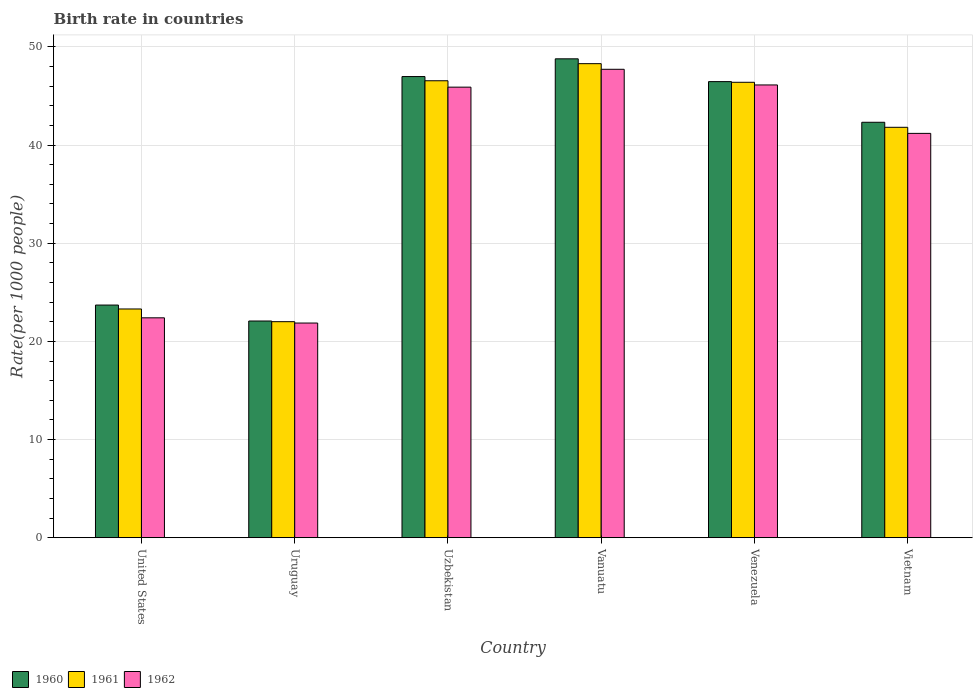Are the number of bars per tick equal to the number of legend labels?
Give a very brief answer. Yes. Are the number of bars on each tick of the X-axis equal?
Provide a short and direct response. Yes. How many bars are there on the 5th tick from the right?
Your response must be concise. 3. What is the label of the 3rd group of bars from the left?
Your answer should be very brief. Uzbekistan. What is the birth rate in 1960 in Uzbekistan?
Your answer should be compact. 46.98. Across all countries, what is the maximum birth rate in 1960?
Your response must be concise. 48.78. Across all countries, what is the minimum birth rate in 1961?
Your response must be concise. 22.01. In which country was the birth rate in 1960 maximum?
Offer a very short reply. Vanuatu. In which country was the birth rate in 1961 minimum?
Offer a terse response. Uruguay. What is the total birth rate in 1960 in the graph?
Offer a very short reply. 230.31. What is the difference between the birth rate in 1962 in Uzbekistan and that in Venezuela?
Make the answer very short. -0.22. What is the difference between the birth rate in 1960 in Vietnam and the birth rate in 1961 in Uruguay?
Offer a terse response. 20.31. What is the average birth rate in 1962 per country?
Your answer should be compact. 37.53. What is the difference between the birth rate of/in 1960 and birth rate of/in 1962 in Uzbekistan?
Offer a terse response. 1.08. In how many countries, is the birth rate in 1961 greater than 36?
Make the answer very short. 4. What is the ratio of the birth rate in 1961 in Venezuela to that in Vietnam?
Your answer should be very brief. 1.11. What is the difference between the highest and the second highest birth rate in 1961?
Your answer should be very brief. 1.9. What is the difference between the highest and the lowest birth rate in 1962?
Ensure brevity in your answer.  25.85. Is the sum of the birth rate in 1960 in Vanuatu and Vietnam greater than the maximum birth rate in 1961 across all countries?
Offer a very short reply. Yes. Are all the bars in the graph horizontal?
Your answer should be compact. No. How many countries are there in the graph?
Offer a terse response. 6. What is the difference between two consecutive major ticks on the Y-axis?
Provide a short and direct response. 10. Are the values on the major ticks of Y-axis written in scientific E-notation?
Offer a terse response. No. Does the graph contain any zero values?
Give a very brief answer. No. Does the graph contain grids?
Your answer should be compact. Yes. How many legend labels are there?
Give a very brief answer. 3. What is the title of the graph?
Ensure brevity in your answer.  Birth rate in countries. What is the label or title of the Y-axis?
Your answer should be compact. Rate(per 1000 people). What is the Rate(per 1000 people) of 1960 in United States?
Your answer should be compact. 23.7. What is the Rate(per 1000 people) of 1961 in United States?
Offer a very short reply. 23.3. What is the Rate(per 1000 people) in 1962 in United States?
Keep it short and to the point. 22.4. What is the Rate(per 1000 people) of 1960 in Uruguay?
Ensure brevity in your answer.  22.07. What is the Rate(per 1000 people) of 1961 in Uruguay?
Make the answer very short. 22.01. What is the Rate(per 1000 people) in 1962 in Uruguay?
Offer a terse response. 21.87. What is the Rate(per 1000 people) of 1960 in Uzbekistan?
Make the answer very short. 46.98. What is the Rate(per 1000 people) of 1961 in Uzbekistan?
Keep it short and to the point. 46.55. What is the Rate(per 1000 people) in 1962 in Uzbekistan?
Give a very brief answer. 45.9. What is the Rate(per 1000 people) in 1960 in Vanuatu?
Provide a succinct answer. 48.78. What is the Rate(per 1000 people) of 1961 in Vanuatu?
Ensure brevity in your answer.  48.29. What is the Rate(per 1000 people) of 1962 in Vanuatu?
Offer a terse response. 47.72. What is the Rate(per 1000 people) of 1960 in Venezuela?
Give a very brief answer. 46.46. What is the Rate(per 1000 people) of 1961 in Venezuela?
Provide a short and direct response. 46.39. What is the Rate(per 1000 people) of 1962 in Venezuela?
Make the answer very short. 46.12. What is the Rate(per 1000 people) in 1960 in Vietnam?
Keep it short and to the point. 42.32. What is the Rate(per 1000 people) in 1961 in Vietnam?
Give a very brief answer. 41.81. What is the Rate(per 1000 people) of 1962 in Vietnam?
Your answer should be very brief. 41.19. Across all countries, what is the maximum Rate(per 1000 people) in 1960?
Provide a short and direct response. 48.78. Across all countries, what is the maximum Rate(per 1000 people) of 1961?
Your answer should be very brief. 48.29. Across all countries, what is the maximum Rate(per 1000 people) of 1962?
Provide a succinct answer. 47.72. Across all countries, what is the minimum Rate(per 1000 people) in 1960?
Your answer should be very brief. 22.07. Across all countries, what is the minimum Rate(per 1000 people) of 1961?
Your response must be concise. 22.01. Across all countries, what is the minimum Rate(per 1000 people) of 1962?
Ensure brevity in your answer.  21.87. What is the total Rate(per 1000 people) in 1960 in the graph?
Your answer should be very brief. 230.31. What is the total Rate(per 1000 people) in 1961 in the graph?
Give a very brief answer. 228.34. What is the total Rate(per 1000 people) of 1962 in the graph?
Give a very brief answer. 225.19. What is the difference between the Rate(per 1000 people) of 1960 in United States and that in Uruguay?
Offer a very short reply. 1.62. What is the difference between the Rate(per 1000 people) of 1961 in United States and that in Uruguay?
Make the answer very short. 1.29. What is the difference between the Rate(per 1000 people) of 1962 in United States and that in Uruguay?
Ensure brevity in your answer.  0.53. What is the difference between the Rate(per 1000 people) of 1960 in United States and that in Uzbekistan?
Offer a terse response. -23.28. What is the difference between the Rate(per 1000 people) of 1961 in United States and that in Uzbekistan?
Make the answer very short. -23.25. What is the difference between the Rate(per 1000 people) of 1962 in United States and that in Uzbekistan?
Offer a very short reply. -23.5. What is the difference between the Rate(per 1000 people) in 1960 in United States and that in Vanuatu?
Your answer should be very brief. -25.08. What is the difference between the Rate(per 1000 people) of 1961 in United States and that in Vanuatu?
Your answer should be very brief. -24.99. What is the difference between the Rate(per 1000 people) of 1962 in United States and that in Vanuatu?
Make the answer very short. -25.32. What is the difference between the Rate(per 1000 people) in 1960 in United States and that in Venezuela?
Your response must be concise. -22.76. What is the difference between the Rate(per 1000 people) in 1961 in United States and that in Venezuela?
Ensure brevity in your answer.  -23.09. What is the difference between the Rate(per 1000 people) of 1962 in United States and that in Venezuela?
Ensure brevity in your answer.  -23.72. What is the difference between the Rate(per 1000 people) of 1960 in United States and that in Vietnam?
Give a very brief answer. -18.62. What is the difference between the Rate(per 1000 people) in 1961 in United States and that in Vietnam?
Your answer should be compact. -18.51. What is the difference between the Rate(per 1000 people) of 1962 in United States and that in Vietnam?
Your answer should be compact. -18.79. What is the difference between the Rate(per 1000 people) in 1960 in Uruguay and that in Uzbekistan?
Your answer should be compact. -24.9. What is the difference between the Rate(per 1000 people) in 1961 in Uruguay and that in Uzbekistan?
Your response must be concise. -24.54. What is the difference between the Rate(per 1000 people) of 1962 in Uruguay and that in Uzbekistan?
Give a very brief answer. -24.03. What is the difference between the Rate(per 1000 people) in 1960 in Uruguay and that in Vanuatu?
Give a very brief answer. -26.71. What is the difference between the Rate(per 1000 people) of 1961 in Uruguay and that in Vanuatu?
Offer a terse response. -26.28. What is the difference between the Rate(per 1000 people) in 1962 in Uruguay and that in Vanuatu?
Provide a short and direct response. -25.85. What is the difference between the Rate(per 1000 people) of 1960 in Uruguay and that in Venezuela?
Keep it short and to the point. -24.39. What is the difference between the Rate(per 1000 people) in 1961 in Uruguay and that in Venezuela?
Give a very brief answer. -24.39. What is the difference between the Rate(per 1000 people) in 1962 in Uruguay and that in Venezuela?
Your answer should be compact. -24.25. What is the difference between the Rate(per 1000 people) of 1960 in Uruguay and that in Vietnam?
Ensure brevity in your answer.  -20.24. What is the difference between the Rate(per 1000 people) in 1961 in Uruguay and that in Vietnam?
Your answer should be very brief. -19.8. What is the difference between the Rate(per 1000 people) of 1962 in Uruguay and that in Vietnam?
Ensure brevity in your answer.  -19.32. What is the difference between the Rate(per 1000 people) in 1960 in Uzbekistan and that in Vanuatu?
Ensure brevity in your answer.  -1.81. What is the difference between the Rate(per 1000 people) in 1961 in Uzbekistan and that in Vanuatu?
Your response must be concise. -1.74. What is the difference between the Rate(per 1000 people) of 1962 in Uzbekistan and that in Vanuatu?
Give a very brief answer. -1.82. What is the difference between the Rate(per 1000 people) in 1960 in Uzbekistan and that in Venezuela?
Ensure brevity in your answer.  0.52. What is the difference between the Rate(per 1000 people) of 1961 in Uzbekistan and that in Venezuela?
Make the answer very short. 0.15. What is the difference between the Rate(per 1000 people) in 1962 in Uzbekistan and that in Venezuela?
Your answer should be compact. -0.22. What is the difference between the Rate(per 1000 people) of 1960 in Uzbekistan and that in Vietnam?
Your response must be concise. 4.66. What is the difference between the Rate(per 1000 people) of 1961 in Uzbekistan and that in Vietnam?
Offer a terse response. 4.74. What is the difference between the Rate(per 1000 people) in 1962 in Uzbekistan and that in Vietnam?
Provide a short and direct response. 4.71. What is the difference between the Rate(per 1000 people) in 1960 in Vanuatu and that in Venezuela?
Offer a very short reply. 2.32. What is the difference between the Rate(per 1000 people) in 1961 in Vanuatu and that in Venezuela?
Offer a terse response. 1.9. What is the difference between the Rate(per 1000 people) of 1962 in Vanuatu and that in Venezuela?
Your answer should be very brief. 1.59. What is the difference between the Rate(per 1000 people) in 1960 in Vanuatu and that in Vietnam?
Ensure brevity in your answer.  6.46. What is the difference between the Rate(per 1000 people) in 1961 in Vanuatu and that in Vietnam?
Keep it short and to the point. 6.48. What is the difference between the Rate(per 1000 people) in 1962 in Vanuatu and that in Vietnam?
Make the answer very short. 6.53. What is the difference between the Rate(per 1000 people) of 1960 in Venezuela and that in Vietnam?
Make the answer very short. 4.14. What is the difference between the Rate(per 1000 people) in 1961 in Venezuela and that in Vietnam?
Keep it short and to the point. 4.59. What is the difference between the Rate(per 1000 people) of 1962 in Venezuela and that in Vietnam?
Provide a short and direct response. 4.93. What is the difference between the Rate(per 1000 people) of 1960 in United States and the Rate(per 1000 people) of 1961 in Uruguay?
Provide a succinct answer. 1.69. What is the difference between the Rate(per 1000 people) in 1960 in United States and the Rate(per 1000 people) in 1962 in Uruguay?
Make the answer very short. 1.83. What is the difference between the Rate(per 1000 people) in 1961 in United States and the Rate(per 1000 people) in 1962 in Uruguay?
Provide a short and direct response. 1.43. What is the difference between the Rate(per 1000 people) in 1960 in United States and the Rate(per 1000 people) in 1961 in Uzbekistan?
Make the answer very short. -22.85. What is the difference between the Rate(per 1000 people) in 1960 in United States and the Rate(per 1000 people) in 1962 in Uzbekistan?
Provide a short and direct response. -22.2. What is the difference between the Rate(per 1000 people) of 1961 in United States and the Rate(per 1000 people) of 1962 in Uzbekistan?
Provide a short and direct response. -22.6. What is the difference between the Rate(per 1000 people) in 1960 in United States and the Rate(per 1000 people) in 1961 in Vanuatu?
Give a very brief answer. -24.59. What is the difference between the Rate(per 1000 people) in 1960 in United States and the Rate(per 1000 people) in 1962 in Vanuatu?
Your answer should be very brief. -24.02. What is the difference between the Rate(per 1000 people) of 1961 in United States and the Rate(per 1000 people) of 1962 in Vanuatu?
Your answer should be compact. -24.42. What is the difference between the Rate(per 1000 people) of 1960 in United States and the Rate(per 1000 people) of 1961 in Venezuela?
Your response must be concise. -22.69. What is the difference between the Rate(per 1000 people) of 1960 in United States and the Rate(per 1000 people) of 1962 in Venezuela?
Provide a short and direct response. -22.42. What is the difference between the Rate(per 1000 people) in 1961 in United States and the Rate(per 1000 people) in 1962 in Venezuela?
Provide a succinct answer. -22.82. What is the difference between the Rate(per 1000 people) of 1960 in United States and the Rate(per 1000 people) of 1961 in Vietnam?
Your response must be concise. -18.11. What is the difference between the Rate(per 1000 people) in 1960 in United States and the Rate(per 1000 people) in 1962 in Vietnam?
Offer a terse response. -17.49. What is the difference between the Rate(per 1000 people) of 1961 in United States and the Rate(per 1000 people) of 1962 in Vietnam?
Offer a terse response. -17.89. What is the difference between the Rate(per 1000 people) of 1960 in Uruguay and the Rate(per 1000 people) of 1961 in Uzbekistan?
Your answer should be compact. -24.47. What is the difference between the Rate(per 1000 people) in 1960 in Uruguay and the Rate(per 1000 people) in 1962 in Uzbekistan?
Keep it short and to the point. -23.82. What is the difference between the Rate(per 1000 people) in 1961 in Uruguay and the Rate(per 1000 people) in 1962 in Uzbekistan?
Give a very brief answer. -23.89. What is the difference between the Rate(per 1000 people) of 1960 in Uruguay and the Rate(per 1000 people) of 1961 in Vanuatu?
Make the answer very short. -26.21. What is the difference between the Rate(per 1000 people) in 1960 in Uruguay and the Rate(per 1000 people) in 1962 in Vanuatu?
Provide a short and direct response. -25.64. What is the difference between the Rate(per 1000 people) of 1961 in Uruguay and the Rate(per 1000 people) of 1962 in Vanuatu?
Make the answer very short. -25.71. What is the difference between the Rate(per 1000 people) of 1960 in Uruguay and the Rate(per 1000 people) of 1961 in Venezuela?
Provide a short and direct response. -24.32. What is the difference between the Rate(per 1000 people) in 1960 in Uruguay and the Rate(per 1000 people) in 1962 in Venezuela?
Your response must be concise. -24.05. What is the difference between the Rate(per 1000 people) in 1961 in Uruguay and the Rate(per 1000 people) in 1962 in Venezuela?
Make the answer very short. -24.11. What is the difference between the Rate(per 1000 people) in 1960 in Uruguay and the Rate(per 1000 people) in 1961 in Vietnam?
Ensure brevity in your answer.  -19.73. What is the difference between the Rate(per 1000 people) of 1960 in Uruguay and the Rate(per 1000 people) of 1962 in Vietnam?
Your response must be concise. -19.11. What is the difference between the Rate(per 1000 people) in 1961 in Uruguay and the Rate(per 1000 people) in 1962 in Vietnam?
Offer a very short reply. -19.18. What is the difference between the Rate(per 1000 people) in 1960 in Uzbekistan and the Rate(per 1000 people) in 1961 in Vanuatu?
Your answer should be very brief. -1.31. What is the difference between the Rate(per 1000 people) of 1960 in Uzbekistan and the Rate(per 1000 people) of 1962 in Vanuatu?
Offer a terse response. -0.74. What is the difference between the Rate(per 1000 people) of 1961 in Uzbekistan and the Rate(per 1000 people) of 1962 in Vanuatu?
Your response must be concise. -1.17. What is the difference between the Rate(per 1000 people) in 1960 in Uzbekistan and the Rate(per 1000 people) in 1961 in Venezuela?
Your response must be concise. 0.58. What is the difference between the Rate(per 1000 people) of 1960 in Uzbekistan and the Rate(per 1000 people) of 1962 in Venezuela?
Your response must be concise. 0.86. What is the difference between the Rate(per 1000 people) of 1961 in Uzbekistan and the Rate(per 1000 people) of 1962 in Venezuela?
Your answer should be compact. 0.43. What is the difference between the Rate(per 1000 people) in 1960 in Uzbekistan and the Rate(per 1000 people) in 1961 in Vietnam?
Provide a succinct answer. 5.17. What is the difference between the Rate(per 1000 people) of 1960 in Uzbekistan and the Rate(per 1000 people) of 1962 in Vietnam?
Ensure brevity in your answer.  5.79. What is the difference between the Rate(per 1000 people) in 1961 in Uzbekistan and the Rate(per 1000 people) in 1962 in Vietnam?
Make the answer very short. 5.36. What is the difference between the Rate(per 1000 people) of 1960 in Vanuatu and the Rate(per 1000 people) of 1961 in Venezuela?
Your response must be concise. 2.39. What is the difference between the Rate(per 1000 people) in 1960 in Vanuatu and the Rate(per 1000 people) in 1962 in Venezuela?
Keep it short and to the point. 2.66. What is the difference between the Rate(per 1000 people) in 1961 in Vanuatu and the Rate(per 1000 people) in 1962 in Venezuela?
Ensure brevity in your answer.  2.17. What is the difference between the Rate(per 1000 people) in 1960 in Vanuatu and the Rate(per 1000 people) in 1961 in Vietnam?
Offer a very short reply. 6.98. What is the difference between the Rate(per 1000 people) in 1960 in Vanuatu and the Rate(per 1000 people) in 1962 in Vietnam?
Offer a very short reply. 7.6. What is the difference between the Rate(per 1000 people) of 1961 in Vanuatu and the Rate(per 1000 people) of 1962 in Vietnam?
Make the answer very short. 7.1. What is the difference between the Rate(per 1000 people) in 1960 in Venezuela and the Rate(per 1000 people) in 1961 in Vietnam?
Give a very brief answer. 4.66. What is the difference between the Rate(per 1000 people) of 1960 in Venezuela and the Rate(per 1000 people) of 1962 in Vietnam?
Provide a succinct answer. 5.27. What is the difference between the Rate(per 1000 people) of 1961 in Venezuela and the Rate(per 1000 people) of 1962 in Vietnam?
Provide a short and direct response. 5.21. What is the average Rate(per 1000 people) in 1960 per country?
Offer a very short reply. 38.39. What is the average Rate(per 1000 people) in 1961 per country?
Provide a short and direct response. 38.06. What is the average Rate(per 1000 people) of 1962 per country?
Make the answer very short. 37.53. What is the difference between the Rate(per 1000 people) in 1960 and Rate(per 1000 people) in 1961 in United States?
Your response must be concise. 0.4. What is the difference between the Rate(per 1000 people) in 1960 and Rate(per 1000 people) in 1962 in United States?
Keep it short and to the point. 1.3. What is the difference between the Rate(per 1000 people) of 1961 and Rate(per 1000 people) of 1962 in United States?
Provide a short and direct response. 0.9. What is the difference between the Rate(per 1000 people) in 1960 and Rate(per 1000 people) in 1961 in Uruguay?
Provide a short and direct response. 0.07. What is the difference between the Rate(per 1000 people) of 1960 and Rate(per 1000 people) of 1962 in Uruguay?
Give a very brief answer. 0.21. What is the difference between the Rate(per 1000 people) of 1961 and Rate(per 1000 people) of 1962 in Uruguay?
Keep it short and to the point. 0.14. What is the difference between the Rate(per 1000 people) in 1960 and Rate(per 1000 people) in 1961 in Uzbekistan?
Make the answer very short. 0.43. What is the difference between the Rate(per 1000 people) of 1960 and Rate(per 1000 people) of 1962 in Uzbekistan?
Give a very brief answer. 1.08. What is the difference between the Rate(per 1000 people) in 1961 and Rate(per 1000 people) in 1962 in Uzbekistan?
Ensure brevity in your answer.  0.65. What is the difference between the Rate(per 1000 people) in 1960 and Rate(per 1000 people) in 1961 in Vanuatu?
Offer a very short reply. 0.49. What is the difference between the Rate(per 1000 people) in 1960 and Rate(per 1000 people) in 1962 in Vanuatu?
Provide a short and direct response. 1.07. What is the difference between the Rate(per 1000 people) of 1961 and Rate(per 1000 people) of 1962 in Vanuatu?
Offer a terse response. 0.57. What is the difference between the Rate(per 1000 people) in 1960 and Rate(per 1000 people) in 1961 in Venezuela?
Offer a very short reply. 0.07. What is the difference between the Rate(per 1000 people) in 1960 and Rate(per 1000 people) in 1962 in Venezuela?
Ensure brevity in your answer.  0.34. What is the difference between the Rate(per 1000 people) of 1961 and Rate(per 1000 people) of 1962 in Venezuela?
Your answer should be very brief. 0.27. What is the difference between the Rate(per 1000 people) in 1960 and Rate(per 1000 people) in 1961 in Vietnam?
Offer a very short reply. 0.51. What is the difference between the Rate(per 1000 people) of 1960 and Rate(per 1000 people) of 1962 in Vietnam?
Keep it short and to the point. 1.13. What is the difference between the Rate(per 1000 people) of 1961 and Rate(per 1000 people) of 1962 in Vietnam?
Offer a terse response. 0.62. What is the ratio of the Rate(per 1000 people) in 1960 in United States to that in Uruguay?
Your answer should be very brief. 1.07. What is the ratio of the Rate(per 1000 people) in 1961 in United States to that in Uruguay?
Provide a short and direct response. 1.06. What is the ratio of the Rate(per 1000 people) in 1962 in United States to that in Uruguay?
Your answer should be very brief. 1.02. What is the ratio of the Rate(per 1000 people) of 1960 in United States to that in Uzbekistan?
Your response must be concise. 0.5. What is the ratio of the Rate(per 1000 people) in 1961 in United States to that in Uzbekistan?
Your response must be concise. 0.5. What is the ratio of the Rate(per 1000 people) of 1962 in United States to that in Uzbekistan?
Make the answer very short. 0.49. What is the ratio of the Rate(per 1000 people) of 1960 in United States to that in Vanuatu?
Give a very brief answer. 0.49. What is the ratio of the Rate(per 1000 people) of 1961 in United States to that in Vanuatu?
Provide a succinct answer. 0.48. What is the ratio of the Rate(per 1000 people) in 1962 in United States to that in Vanuatu?
Make the answer very short. 0.47. What is the ratio of the Rate(per 1000 people) of 1960 in United States to that in Venezuela?
Provide a succinct answer. 0.51. What is the ratio of the Rate(per 1000 people) in 1961 in United States to that in Venezuela?
Provide a succinct answer. 0.5. What is the ratio of the Rate(per 1000 people) of 1962 in United States to that in Venezuela?
Your answer should be compact. 0.49. What is the ratio of the Rate(per 1000 people) of 1960 in United States to that in Vietnam?
Give a very brief answer. 0.56. What is the ratio of the Rate(per 1000 people) of 1961 in United States to that in Vietnam?
Ensure brevity in your answer.  0.56. What is the ratio of the Rate(per 1000 people) in 1962 in United States to that in Vietnam?
Offer a very short reply. 0.54. What is the ratio of the Rate(per 1000 people) of 1960 in Uruguay to that in Uzbekistan?
Keep it short and to the point. 0.47. What is the ratio of the Rate(per 1000 people) in 1961 in Uruguay to that in Uzbekistan?
Your answer should be very brief. 0.47. What is the ratio of the Rate(per 1000 people) in 1962 in Uruguay to that in Uzbekistan?
Your answer should be compact. 0.48. What is the ratio of the Rate(per 1000 people) of 1960 in Uruguay to that in Vanuatu?
Offer a terse response. 0.45. What is the ratio of the Rate(per 1000 people) in 1961 in Uruguay to that in Vanuatu?
Give a very brief answer. 0.46. What is the ratio of the Rate(per 1000 people) in 1962 in Uruguay to that in Vanuatu?
Your response must be concise. 0.46. What is the ratio of the Rate(per 1000 people) of 1960 in Uruguay to that in Venezuela?
Give a very brief answer. 0.48. What is the ratio of the Rate(per 1000 people) in 1961 in Uruguay to that in Venezuela?
Your response must be concise. 0.47. What is the ratio of the Rate(per 1000 people) of 1962 in Uruguay to that in Venezuela?
Give a very brief answer. 0.47. What is the ratio of the Rate(per 1000 people) in 1960 in Uruguay to that in Vietnam?
Your answer should be very brief. 0.52. What is the ratio of the Rate(per 1000 people) in 1961 in Uruguay to that in Vietnam?
Give a very brief answer. 0.53. What is the ratio of the Rate(per 1000 people) of 1962 in Uruguay to that in Vietnam?
Make the answer very short. 0.53. What is the ratio of the Rate(per 1000 people) of 1961 in Uzbekistan to that in Vanuatu?
Keep it short and to the point. 0.96. What is the ratio of the Rate(per 1000 people) in 1962 in Uzbekistan to that in Vanuatu?
Provide a short and direct response. 0.96. What is the ratio of the Rate(per 1000 people) of 1960 in Uzbekistan to that in Venezuela?
Make the answer very short. 1.01. What is the ratio of the Rate(per 1000 people) of 1960 in Uzbekistan to that in Vietnam?
Provide a short and direct response. 1.11. What is the ratio of the Rate(per 1000 people) of 1961 in Uzbekistan to that in Vietnam?
Your answer should be compact. 1.11. What is the ratio of the Rate(per 1000 people) of 1962 in Uzbekistan to that in Vietnam?
Your answer should be very brief. 1.11. What is the ratio of the Rate(per 1000 people) in 1961 in Vanuatu to that in Venezuela?
Ensure brevity in your answer.  1.04. What is the ratio of the Rate(per 1000 people) of 1962 in Vanuatu to that in Venezuela?
Provide a short and direct response. 1.03. What is the ratio of the Rate(per 1000 people) in 1960 in Vanuatu to that in Vietnam?
Keep it short and to the point. 1.15. What is the ratio of the Rate(per 1000 people) in 1961 in Vanuatu to that in Vietnam?
Your answer should be compact. 1.16. What is the ratio of the Rate(per 1000 people) of 1962 in Vanuatu to that in Vietnam?
Your answer should be compact. 1.16. What is the ratio of the Rate(per 1000 people) in 1960 in Venezuela to that in Vietnam?
Offer a terse response. 1.1. What is the ratio of the Rate(per 1000 people) in 1961 in Venezuela to that in Vietnam?
Keep it short and to the point. 1.11. What is the ratio of the Rate(per 1000 people) in 1962 in Venezuela to that in Vietnam?
Keep it short and to the point. 1.12. What is the difference between the highest and the second highest Rate(per 1000 people) in 1960?
Keep it short and to the point. 1.81. What is the difference between the highest and the second highest Rate(per 1000 people) of 1961?
Offer a very short reply. 1.74. What is the difference between the highest and the second highest Rate(per 1000 people) in 1962?
Offer a terse response. 1.59. What is the difference between the highest and the lowest Rate(per 1000 people) in 1960?
Your answer should be very brief. 26.71. What is the difference between the highest and the lowest Rate(per 1000 people) in 1961?
Make the answer very short. 26.28. What is the difference between the highest and the lowest Rate(per 1000 people) in 1962?
Offer a very short reply. 25.85. 